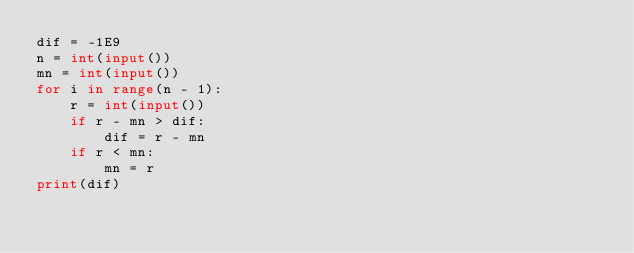Convert code to text. <code><loc_0><loc_0><loc_500><loc_500><_Python_>dif = -1E9
n = int(input())
mn = int(input())
for i in range(n - 1):
    r = int(input())
    if r - mn > dif:
        dif = r - mn
    if r < mn:
        mn = r
print(dif)</code> 